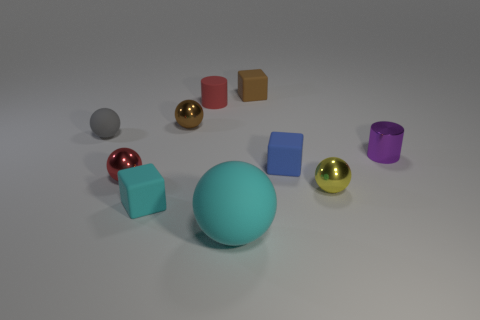Subtract all yellow balls. How many balls are left? 4 Subtract all green spheres. Subtract all gray cylinders. How many spheres are left? 5 Subtract all cylinders. How many objects are left? 8 Add 7 small purple metal cylinders. How many small purple metal cylinders are left? 8 Add 5 large cyan matte things. How many large cyan matte things exist? 6 Subtract 1 yellow spheres. How many objects are left? 9 Subtract all tiny yellow shiny things. Subtract all big yellow metal cylinders. How many objects are left? 9 